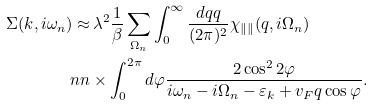Convert formula to latex. <formula><loc_0><loc_0><loc_500><loc_500>\Sigma ( { k } , i \omega _ { n } ) \approx & \, \lambda ^ { 2 } \frac { 1 } { \beta } \sum _ { \Omega _ { n } } \int _ { 0 } ^ { \infty } \frac { d q q } { ( 2 \pi ) ^ { 2 } } \chi _ { \| \| } ( q , i \Omega _ { n } ) \\ \ n n & \times \int _ { 0 } ^ { 2 \pi } d \varphi \frac { 2 \cos ^ { 2 } 2 \varphi } { i \omega _ { n } - i \Omega _ { n } - \varepsilon _ { k } + v _ { F } q \cos \varphi } .</formula> 